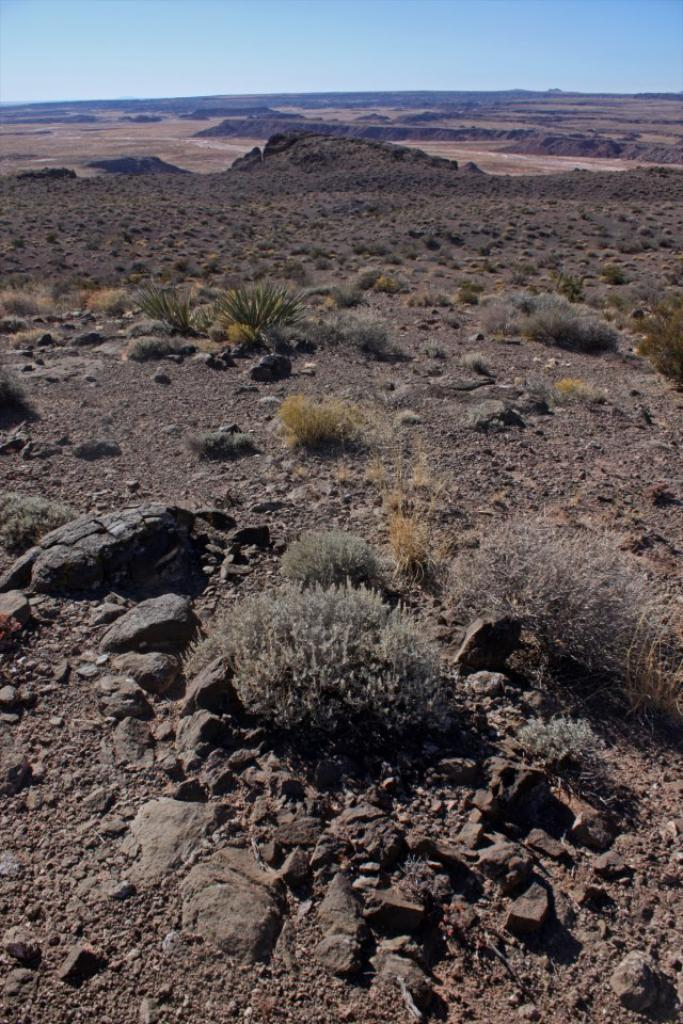What is on the ground in the image? There are stones and plants on the ground in the image. What can be seen in the background of the image? The sky is visible in the background of the image. How many firemen are present in the image? There are no firemen present in the image. What is the rate of expansion of the plants in the image? The image is a still photograph, so it does not show the rate of expansion of the plants. 